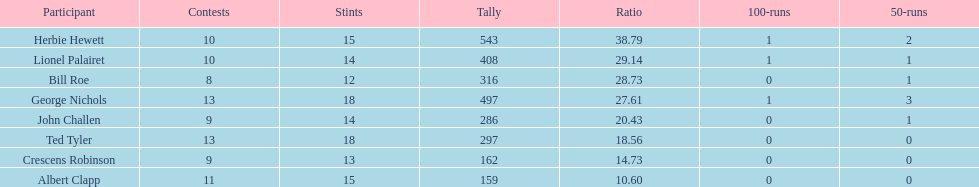Name a player that play in no more than 13 innings. Bill Roe. 